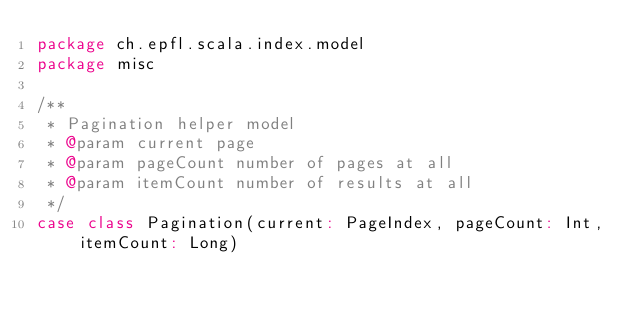<code> <loc_0><loc_0><loc_500><loc_500><_Scala_>package ch.epfl.scala.index.model
package misc

/**
 * Pagination helper model
 * @param current page
 * @param pageCount number of pages at all
 * @param itemCount number of results at all
 */
case class Pagination(current: PageIndex, pageCount: Int, itemCount: Long)
</code> 